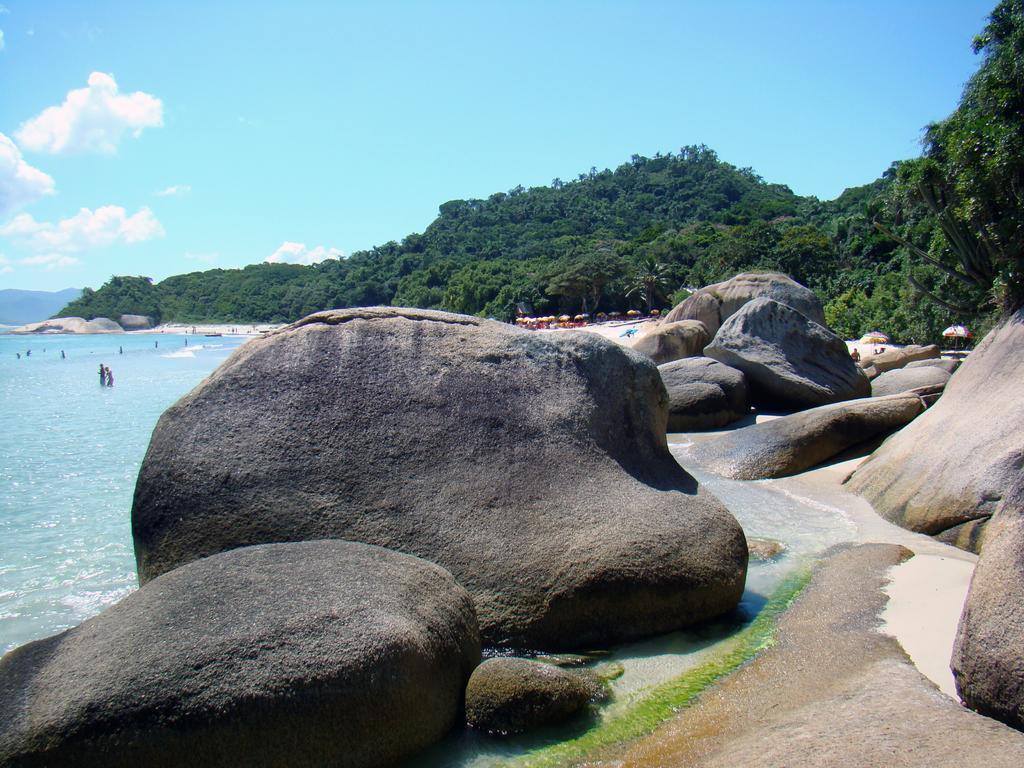Could you give a brief overview of what you see in this image? We can see rocks and water. In the background we can see people,trees and sky with clouds. 